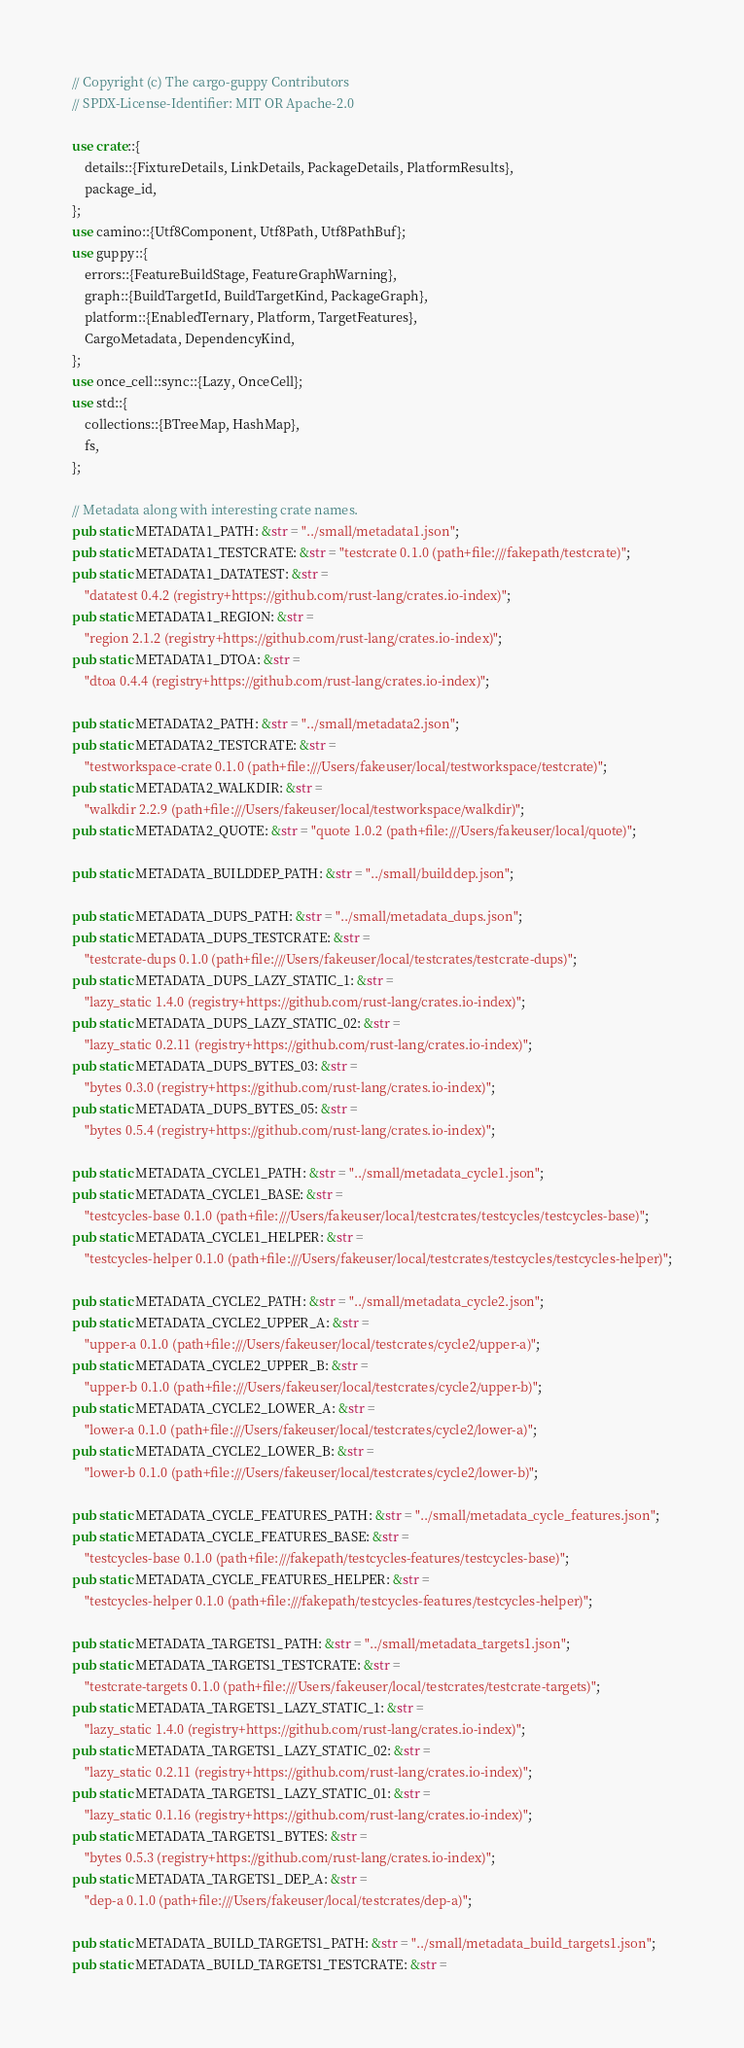Convert code to text. <code><loc_0><loc_0><loc_500><loc_500><_Rust_>// Copyright (c) The cargo-guppy Contributors
// SPDX-License-Identifier: MIT OR Apache-2.0

use crate::{
    details::{FixtureDetails, LinkDetails, PackageDetails, PlatformResults},
    package_id,
};
use camino::{Utf8Component, Utf8Path, Utf8PathBuf};
use guppy::{
    errors::{FeatureBuildStage, FeatureGraphWarning},
    graph::{BuildTargetId, BuildTargetKind, PackageGraph},
    platform::{EnabledTernary, Platform, TargetFeatures},
    CargoMetadata, DependencyKind,
};
use once_cell::sync::{Lazy, OnceCell};
use std::{
    collections::{BTreeMap, HashMap},
    fs,
};

// Metadata along with interesting crate names.
pub static METADATA1_PATH: &str = "../small/metadata1.json";
pub static METADATA1_TESTCRATE: &str = "testcrate 0.1.0 (path+file:///fakepath/testcrate)";
pub static METADATA1_DATATEST: &str =
    "datatest 0.4.2 (registry+https://github.com/rust-lang/crates.io-index)";
pub static METADATA1_REGION: &str =
    "region 2.1.2 (registry+https://github.com/rust-lang/crates.io-index)";
pub static METADATA1_DTOA: &str =
    "dtoa 0.4.4 (registry+https://github.com/rust-lang/crates.io-index)";

pub static METADATA2_PATH: &str = "../small/metadata2.json";
pub static METADATA2_TESTCRATE: &str =
    "testworkspace-crate 0.1.0 (path+file:///Users/fakeuser/local/testworkspace/testcrate)";
pub static METADATA2_WALKDIR: &str =
    "walkdir 2.2.9 (path+file:///Users/fakeuser/local/testworkspace/walkdir)";
pub static METADATA2_QUOTE: &str = "quote 1.0.2 (path+file:///Users/fakeuser/local/quote)";

pub static METADATA_BUILDDEP_PATH: &str = "../small/builddep.json";

pub static METADATA_DUPS_PATH: &str = "../small/metadata_dups.json";
pub static METADATA_DUPS_TESTCRATE: &str =
    "testcrate-dups 0.1.0 (path+file:///Users/fakeuser/local/testcrates/testcrate-dups)";
pub static METADATA_DUPS_LAZY_STATIC_1: &str =
    "lazy_static 1.4.0 (registry+https://github.com/rust-lang/crates.io-index)";
pub static METADATA_DUPS_LAZY_STATIC_02: &str =
    "lazy_static 0.2.11 (registry+https://github.com/rust-lang/crates.io-index)";
pub static METADATA_DUPS_BYTES_03: &str =
    "bytes 0.3.0 (registry+https://github.com/rust-lang/crates.io-index)";
pub static METADATA_DUPS_BYTES_05: &str =
    "bytes 0.5.4 (registry+https://github.com/rust-lang/crates.io-index)";

pub static METADATA_CYCLE1_PATH: &str = "../small/metadata_cycle1.json";
pub static METADATA_CYCLE1_BASE: &str =
    "testcycles-base 0.1.0 (path+file:///Users/fakeuser/local/testcrates/testcycles/testcycles-base)";
pub static METADATA_CYCLE1_HELPER: &str =
    "testcycles-helper 0.1.0 (path+file:///Users/fakeuser/local/testcrates/testcycles/testcycles-helper)";

pub static METADATA_CYCLE2_PATH: &str = "../small/metadata_cycle2.json";
pub static METADATA_CYCLE2_UPPER_A: &str =
    "upper-a 0.1.0 (path+file:///Users/fakeuser/local/testcrates/cycle2/upper-a)";
pub static METADATA_CYCLE2_UPPER_B: &str =
    "upper-b 0.1.0 (path+file:///Users/fakeuser/local/testcrates/cycle2/upper-b)";
pub static METADATA_CYCLE2_LOWER_A: &str =
    "lower-a 0.1.0 (path+file:///Users/fakeuser/local/testcrates/cycle2/lower-a)";
pub static METADATA_CYCLE2_LOWER_B: &str =
    "lower-b 0.1.0 (path+file:///Users/fakeuser/local/testcrates/cycle2/lower-b)";

pub static METADATA_CYCLE_FEATURES_PATH: &str = "../small/metadata_cycle_features.json";
pub static METADATA_CYCLE_FEATURES_BASE: &str =
    "testcycles-base 0.1.0 (path+file:///fakepath/testcycles-features/testcycles-base)";
pub static METADATA_CYCLE_FEATURES_HELPER: &str =
    "testcycles-helper 0.1.0 (path+file:///fakepath/testcycles-features/testcycles-helper)";

pub static METADATA_TARGETS1_PATH: &str = "../small/metadata_targets1.json";
pub static METADATA_TARGETS1_TESTCRATE: &str =
    "testcrate-targets 0.1.0 (path+file:///Users/fakeuser/local/testcrates/testcrate-targets)";
pub static METADATA_TARGETS1_LAZY_STATIC_1: &str =
    "lazy_static 1.4.0 (registry+https://github.com/rust-lang/crates.io-index)";
pub static METADATA_TARGETS1_LAZY_STATIC_02: &str =
    "lazy_static 0.2.11 (registry+https://github.com/rust-lang/crates.io-index)";
pub static METADATA_TARGETS1_LAZY_STATIC_01: &str =
    "lazy_static 0.1.16 (registry+https://github.com/rust-lang/crates.io-index)";
pub static METADATA_TARGETS1_BYTES: &str =
    "bytes 0.5.3 (registry+https://github.com/rust-lang/crates.io-index)";
pub static METADATA_TARGETS1_DEP_A: &str =
    "dep-a 0.1.0 (path+file:///Users/fakeuser/local/testcrates/dep-a)";

pub static METADATA_BUILD_TARGETS1_PATH: &str = "../small/metadata_build_targets1.json";
pub static METADATA_BUILD_TARGETS1_TESTCRATE: &str =</code> 